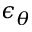<formula> <loc_0><loc_0><loc_500><loc_500>\epsilon _ { \theta }</formula> 